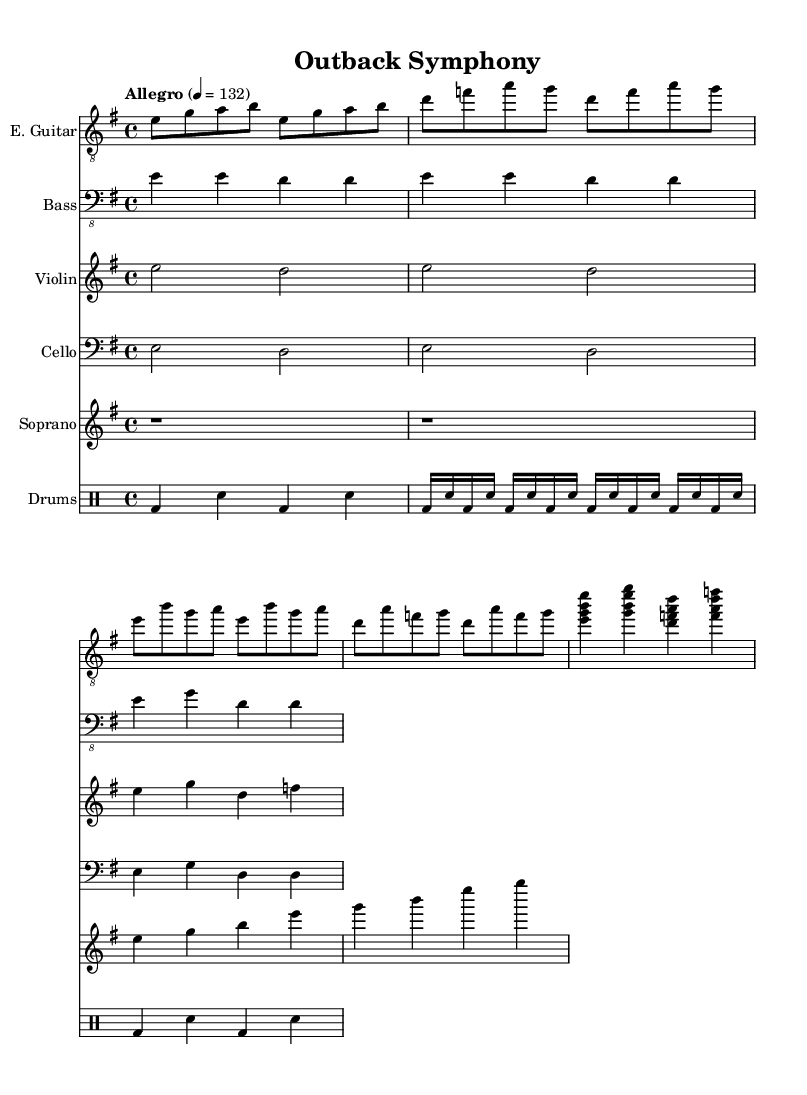What is the key signature of this music? The key signature is indicated at the beginning of the staff, showing one sharp. This means the music is in E minor.
Answer: E minor What is the time signature? The time signature is specified next to the key signature at the beginning of the score, showing a 4 over 4; this indicates there are four beats in each measure.
Answer: 4/4 What is the tempo marking? The tempo marking is found in the header section of the score and states "Allegro" with a metronome marking of 132, indicating a fast tempo.
Answer: Allegro 4 = 132 What instruments are present in this score? By looking at the new staff labels in the score, we can identify the instruments included: E. Guitar, Bass, Violin, Cello, Soprano, and Drums.
Answer: E. Guitar, Bass, Violin, Cello, Soprano, Drums How many measures does the chorus section have? Observing the section labeled "Chorus", we count the measures present, which totals four measures that make up the chorus.
Answer: 4 What type of drumming pattern is used in the verse? In the verse section, the drumming part consists of rapid beats displayed as 16th note blast beats, indicating a fast-paced drumming style typical in metal.
Answer: Blast beats Which section introduces the string instruments? The string instruments (violin and cello) are introduced first in the Intro section, where they both play the same notes indicating a harmonious entry.
Answer: Intro 